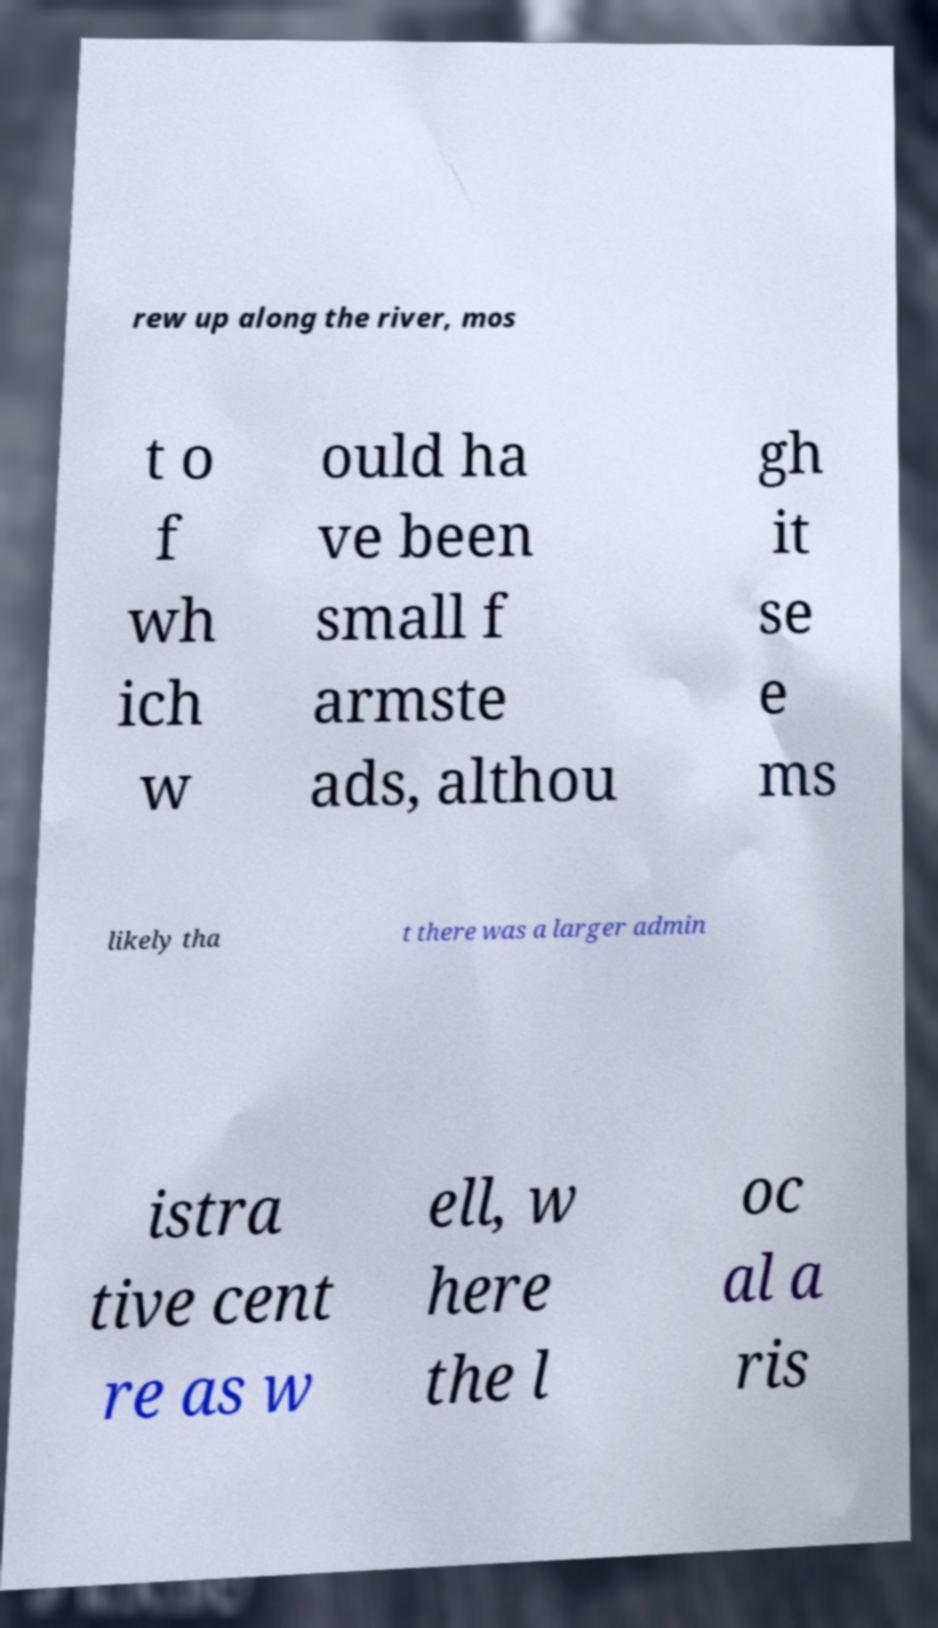Can you read and provide the text displayed in the image?This photo seems to have some interesting text. Can you extract and type it out for me? rew up along the river, mos t o f wh ich w ould ha ve been small f armste ads, althou gh it se e ms likely tha t there was a larger admin istra tive cent re as w ell, w here the l oc al a ris 